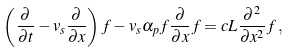Convert formula to latex. <formula><loc_0><loc_0><loc_500><loc_500>\left ( \frac { \partial } { \partial t } - v _ { s } \frac { \partial } { \partial x } \right ) f - v _ { s } \alpha _ { p } f \frac { \partial } { \partial x } f = c L \frac { \partial ^ { 2 } } { \partial x ^ { 2 } } f \, ,</formula> 